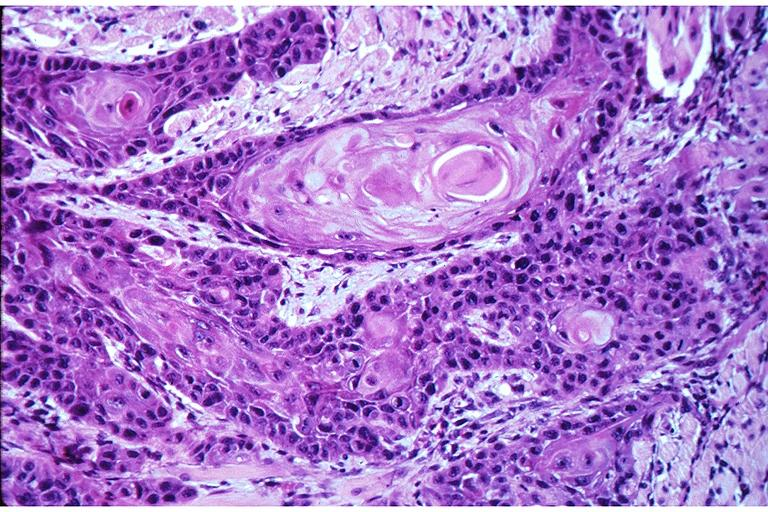s mucoepidermoid carcinoma present?
Answer the question using a single word or phrase. No 